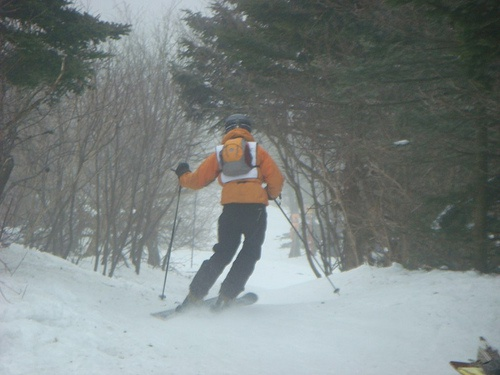Describe the objects in this image and their specific colors. I can see people in black, gray, darkgray, and tan tones, backpack in black, gray, and tan tones, and skis in black, darkgray, gray, and lightblue tones in this image. 